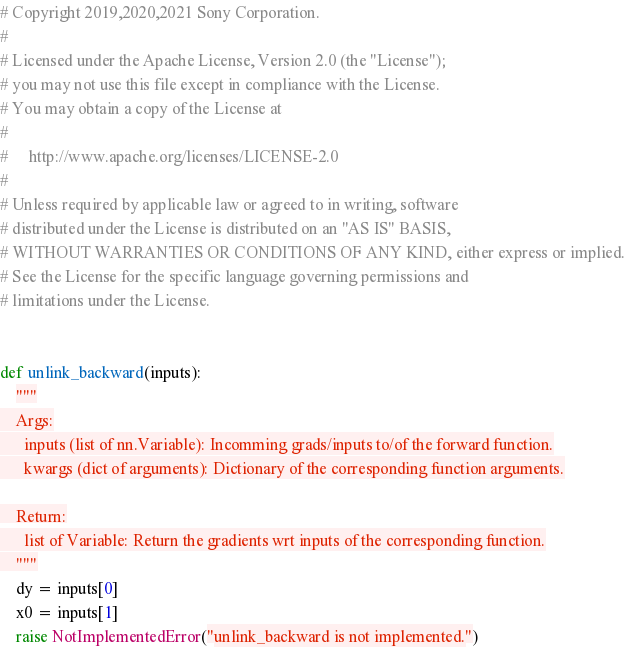<code> <loc_0><loc_0><loc_500><loc_500><_Python_># Copyright 2019,2020,2021 Sony Corporation.
#
# Licensed under the Apache License, Version 2.0 (the "License");
# you may not use this file except in compliance with the License.
# You may obtain a copy of the License at
#
#     http://www.apache.org/licenses/LICENSE-2.0
#
# Unless required by applicable law or agreed to in writing, software
# distributed under the License is distributed on an "AS IS" BASIS,
# WITHOUT WARRANTIES OR CONDITIONS OF ANY KIND, either express or implied.
# See the License for the specific language governing permissions and
# limitations under the License.


def unlink_backward(inputs):
    """
    Args:
      inputs (list of nn.Variable): Incomming grads/inputs to/of the forward function.
      kwargs (dict of arguments): Dictionary of the corresponding function arguments.

    Return:
      list of Variable: Return the gradients wrt inputs of the corresponding function.
    """
    dy = inputs[0]
    x0 = inputs[1]
    raise NotImplementedError("unlink_backward is not implemented.")
</code> 